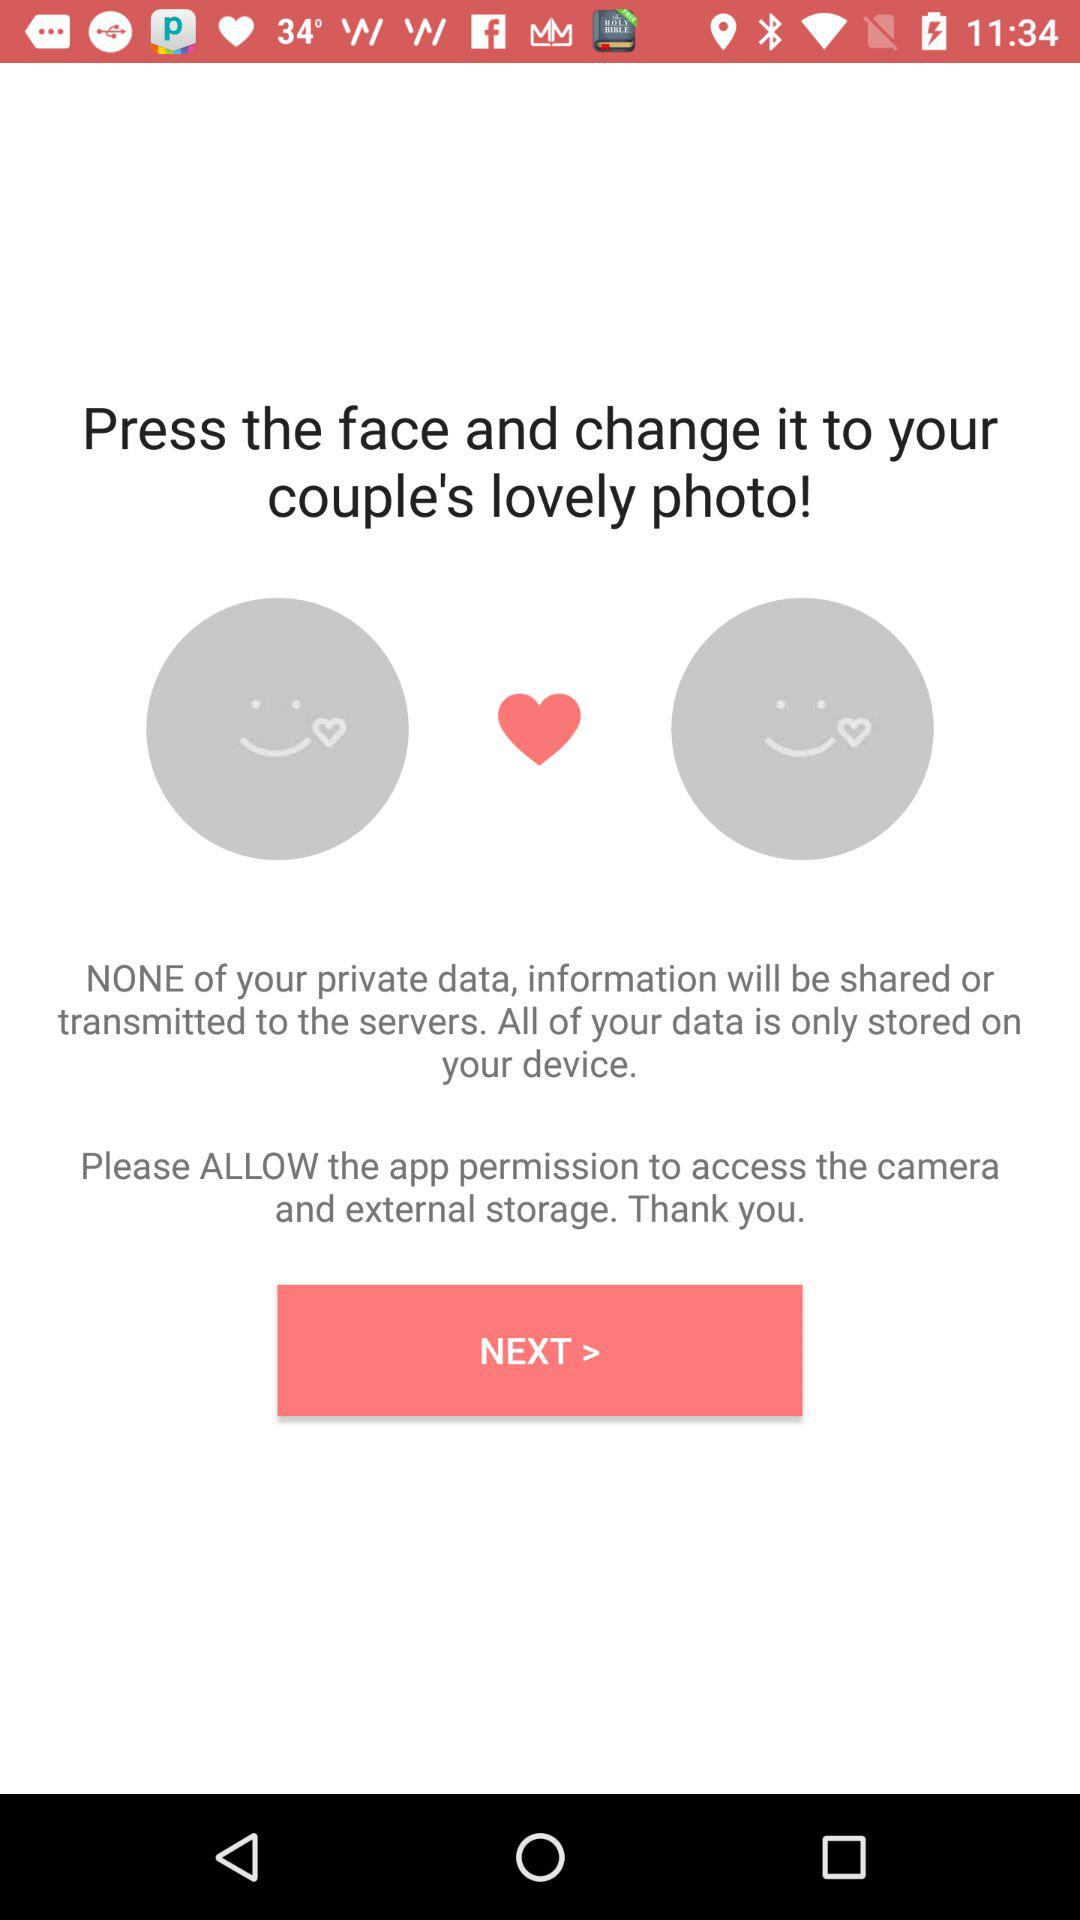How many happy faces are there on the screen?
Answer the question using a single word or phrase. 2 